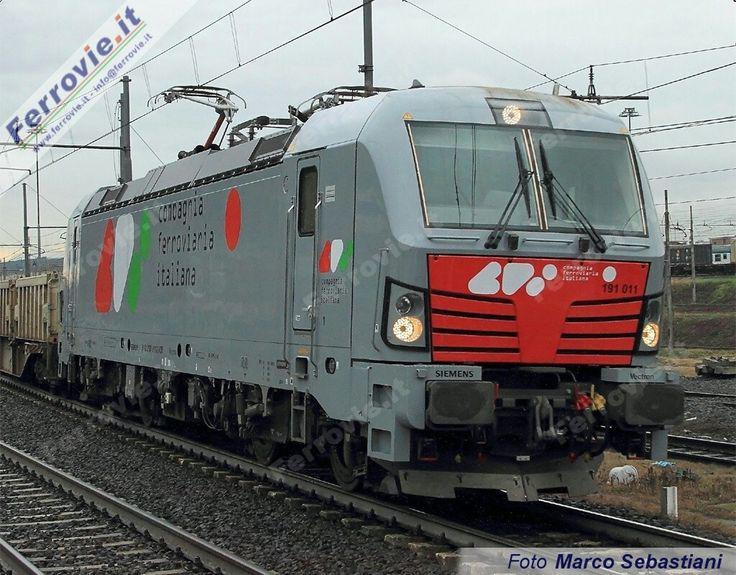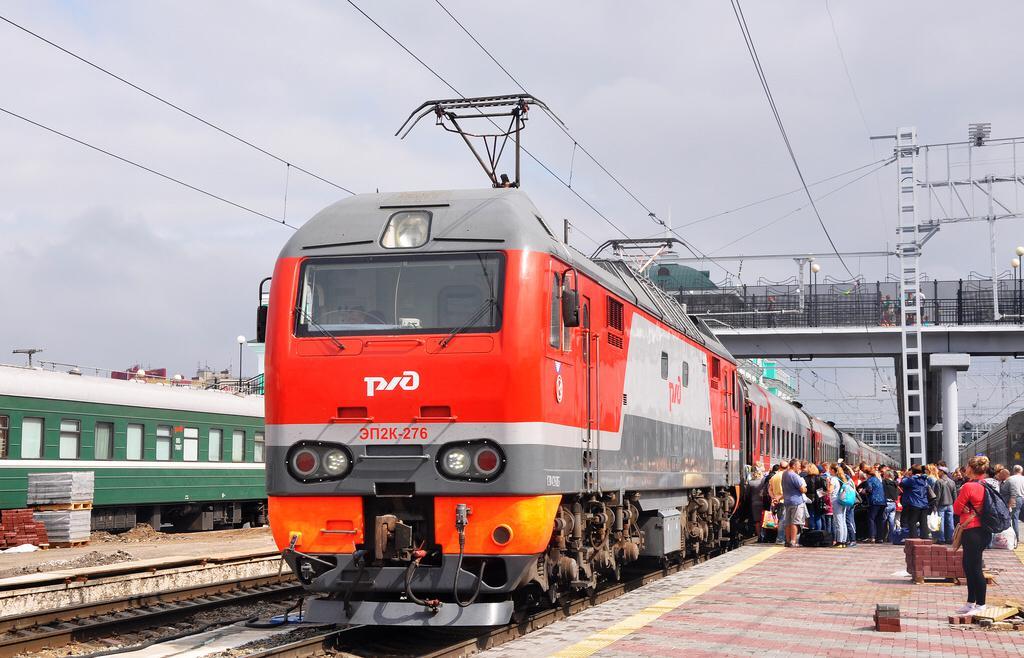The first image is the image on the left, the second image is the image on the right. Considering the images on both sides, is "Both trains are predominately red headed in the same direction." valid? Answer yes or no. No. 